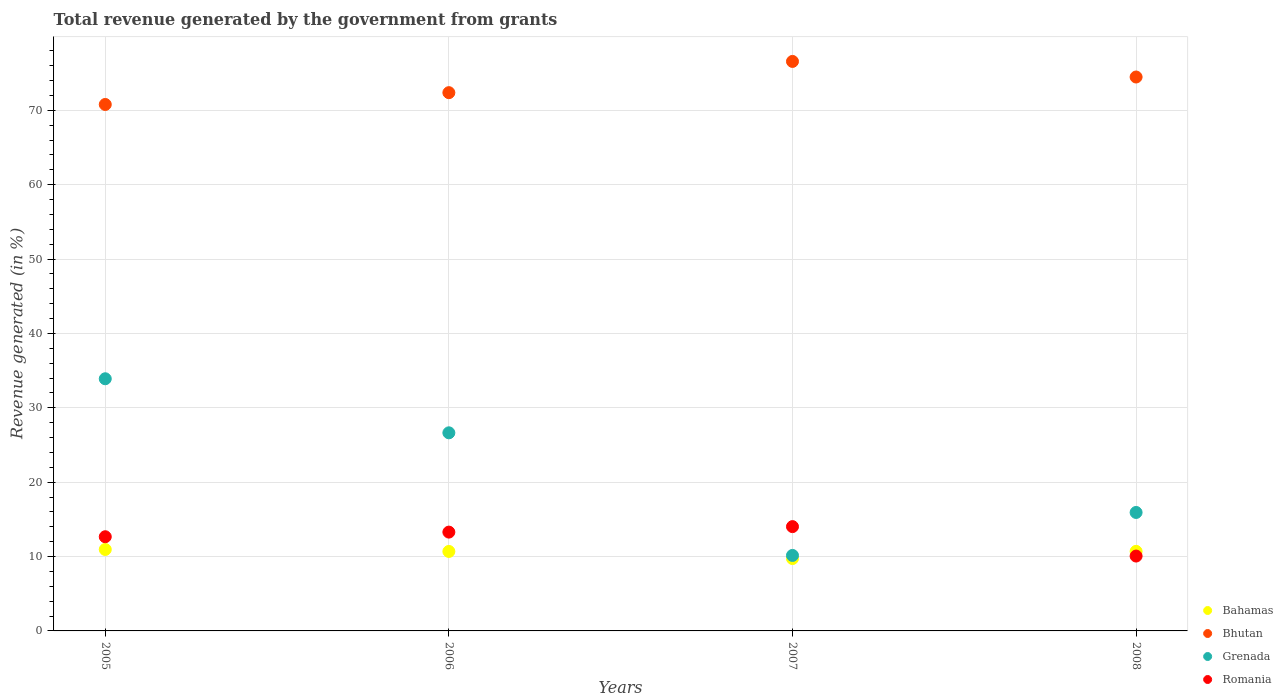How many different coloured dotlines are there?
Offer a very short reply. 4. What is the total revenue generated in Bhutan in 2007?
Your answer should be very brief. 76.57. Across all years, what is the maximum total revenue generated in Grenada?
Offer a very short reply. 33.9. Across all years, what is the minimum total revenue generated in Romania?
Provide a succinct answer. 10.07. In which year was the total revenue generated in Grenada maximum?
Your answer should be very brief. 2005. What is the total total revenue generated in Romania in the graph?
Provide a succinct answer. 50.04. What is the difference between the total revenue generated in Romania in 2007 and that in 2008?
Offer a terse response. 3.96. What is the difference between the total revenue generated in Grenada in 2006 and the total revenue generated in Bhutan in 2007?
Give a very brief answer. -49.93. What is the average total revenue generated in Bhutan per year?
Provide a succinct answer. 73.55. In the year 2008, what is the difference between the total revenue generated in Bhutan and total revenue generated in Romania?
Keep it short and to the point. 64.41. In how many years, is the total revenue generated in Grenada greater than 58 %?
Provide a succinct answer. 0. What is the ratio of the total revenue generated in Bahamas in 2007 to that in 2008?
Offer a terse response. 0.91. What is the difference between the highest and the second highest total revenue generated in Romania?
Provide a succinct answer. 0.74. What is the difference between the highest and the lowest total revenue generated in Bhutan?
Offer a terse response. 5.79. In how many years, is the total revenue generated in Bhutan greater than the average total revenue generated in Bhutan taken over all years?
Your answer should be compact. 2. Is it the case that in every year, the sum of the total revenue generated in Romania and total revenue generated in Bhutan  is greater than the total revenue generated in Grenada?
Give a very brief answer. Yes. Does the total revenue generated in Romania monotonically increase over the years?
Your response must be concise. No. What is the difference between two consecutive major ticks on the Y-axis?
Offer a very short reply. 10. Does the graph contain any zero values?
Provide a short and direct response. No. Does the graph contain grids?
Your answer should be compact. Yes. Where does the legend appear in the graph?
Offer a terse response. Bottom right. How many legend labels are there?
Provide a succinct answer. 4. How are the legend labels stacked?
Provide a short and direct response. Vertical. What is the title of the graph?
Ensure brevity in your answer.  Total revenue generated by the government from grants. Does "Korea (Republic)" appear as one of the legend labels in the graph?
Your response must be concise. No. What is the label or title of the X-axis?
Ensure brevity in your answer.  Years. What is the label or title of the Y-axis?
Your response must be concise. Revenue generated (in %). What is the Revenue generated (in %) of Bahamas in 2005?
Provide a short and direct response. 10.95. What is the Revenue generated (in %) of Bhutan in 2005?
Provide a succinct answer. 70.78. What is the Revenue generated (in %) in Grenada in 2005?
Offer a terse response. 33.9. What is the Revenue generated (in %) in Romania in 2005?
Keep it short and to the point. 12.66. What is the Revenue generated (in %) in Bahamas in 2006?
Your answer should be compact. 10.69. What is the Revenue generated (in %) of Bhutan in 2006?
Give a very brief answer. 72.37. What is the Revenue generated (in %) in Grenada in 2006?
Your answer should be very brief. 26.64. What is the Revenue generated (in %) in Romania in 2006?
Offer a very short reply. 13.29. What is the Revenue generated (in %) in Bahamas in 2007?
Your response must be concise. 9.73. What is the Revenue generated (in %) in Bhutan in 2007?
Your answer should be compact. 76.57. What is the Revenue generated (in %) of Grenada in 2007?
Provide a short and direct response. 10.15. What is the Revenue generated (in %) of Romania in 2007?
Your answer should be very brief. 14.02. What is the Revenue generated (in %) of Bahamas in 2008?
Keep it short and to the point. 10.7. What is the Revenue generated (in %) of Bhutan in 2008?
Keep it short and to the point. 74.48. What is the Revenue generated (in %) in Grenada in 2008?
Offer a terse response. 15.93. What is the Revenue generated (in %) in Romania in 2008?
Provide a succinct answer. 10.07. Across all years, what is the maximum Revenue generated (in %) in Bahamas?
Keep it short and to the point. 10.95. Across all years, what is the maximum Revenue generated (in %) of Bhutan?
Make the answer very short. 76.57. Across all years, what is the maximum Revenue generated (in %) of Grenada?
Your answer should be very brief. 33.9. Across all years, what is the maximum Revenue generated (in %) in Romania?
Keep it short and to the point. 14.02. Across all years, what is the minimum Revenue generated (in %) in Bahamas?
Provide a short and direct response. 9.73. Across all years, what is the minimum Revenue generated (in %) of Bhutan?
Your answer should be compact. 70.78. Across all years, what is the minimum Revenue generated (in %) in Grenada?
Your answer should be very brief. 10.15. Across all years, what is the minimum Revenue generated (in %) of Romania?
Your answer should be very brief. 10.07. What is the total Revenue generated (in %) of Bahamas in the graph?
Offer a very short reply. 42.06. What is the total Revenue generated (in %) of Bhutan in the graph?
Provide a succinct answer. 294.2. What is the total Revenue generated (in %) in Grenada in the graph?
Your response must be concise. 86.62. What is the total Revenue generated (in %) in Romania in the graph?
Keep it short and to the point. 50.04. What is the difference between the Revenue generated (in %) of Bahamas in 2005 and that in 2006?
Offer a terse response. 0.26. What is the difference between the Revenue generated (in %) in Bhutan in 2005 and that in 2006?
Provide a succinct answer. -1.59. What is the difference between the Revenue generated (in %) in Grenada in 2005 and that in 2006?
Make the answer very short. 7.27. What is the difference between the Revenue generated (in %) in Romania in 2005 and that in 2006?
Provide a succinct answer. -0.62. What is the difference between the Revenue generated (in %) of Bahamas in 2005 and that in 2007?
Offer a very short reply. 1.22. What is the difference between the Revenue generated (in %) of Bhutan in 2005 and that in 2007?
Your response must be concise. -5.79. What is the difference between the Revenue generated (in %) of Grenada in 2005 and that in 2007?
Keep it short and to the point. 23.75. What is the difference between the Revenue generated (in %) of Romania in 2005 and that in 2007?
Offer a very short reply. -1.36. What is the difference between the Revenue generated (in %) of Bahamas in 2005 and that in 2008?
Make the answer very short. 0.25. What is the difference between the Revenue generated (in %) in Bhutan in 2005 and that in 2008?
Your response must be concise. -3.69. What is the difference between the Revenue generated (in %) in Grenada in 2005 and that in 2008?
Offer a terse response. 17.98. What is the difference between the Revenue generated (in %) in Romania in 2005 and that in 2008?
Give a very brief answer. 2.6. What is the difference between the Revenue generated (in %) of Bahamas in 2006 and that in 2007?
Your answer should be compact. 0.96. What is the difference between the Revenue generated (in %) of Bhutan in 2006 and that in 2007?
Offer a terse response. -4.2. What is the difference between the Revenue generated (in %) of Grenada in 2006 and that in 2007?
Offer a terse response. 16.49. What is the difference between the Revenue generated (in %) of Romania in 2006 and that in 2007?
Offer a very short reply. -0.74. What is the difference between the Revenue generated (in %) of Bahamas in 2006 and that in 2008?
Give a very brief answer. -0.01. What is the difference between the Revenue generated (in %) of Bhutan in 2006 and that in 2008?
Your response must be concise. -2.1. What is the difference between the Revenue generated (in %) in Grenada in 2006 and that in 2008?
Give a very brief answer. 10.71. What is the difference between the Revenue generated (in %) in Romania in 2006 and that in 2008?
Your answer should be compact. 3.22. What is the difference between the Revenue generated (in %) in Bahamas in 2007 and that in 2008?
Provide a succinct answer. -0.97. What is the difference between the Revenue generated (in %) of Bhutan in 2007 and that in 2008?
Your response must be concise. 2.09. What is the difference between the Revenue generated (in %) of Grenada in 2007 and that in 2008?
Keep it short and to the point. -5.78. What is the difference between the Revenue generated (in %) in Romania in 2007 and that in 2008?
Offer a terse response. 3.96. What is the difference between the Revenue generated (in %) of Bahamas in 2005 and the Revenue generated (in %) of Bhutan in 2006?
Your answer should be very brief. -61.42. What is the difference between the Revenue generated (in %) of Bahamas in 2005 and the Revenue generated (in %) of Grenada in 2006?
Keep it short and to the point. -15.68. What is the difference between the Revenue generated (in %) of Bahamas in 2005 and the Revenue generated (in %) of Romania in 2006?
Offer a terse response. -2.33. What is the difference between the Revenue generated (in %) of Bhutan in 2005 and the Revenue generated (in %) of Grenada in 2006?
Make the answer very short. 44.15. What is the difference between the Revenue generated (in %) of Bhutan in 2005 and the Revenue generated (in %) of Romania in 2006?
Give a very brief answer. 57.5. What is the difference between the Revenue generated (in %) in Grenada in 2005 and the Revenue generated (in %) in Romania in 2006?
Make the answer very short. 20.62. What is the difference between the Revenue generated (in %) of Bahamas in 2005 and the Revenue generated (in %) of Bhutan in 2007?
Your answer should be compact. -65.62. What is the difference between the Revenue generated (in %) in Bahamas in 2005 and the Revenue generated (in %) in Grenada in 2007?
Make the answer very short. 0.8. What is the difference between the Revenue generated (in %) of Bahamas in 2005 and the Revenue generated (in %) of Romania in 2007?
Offer a terse response. -3.07. What is the difference between the Revenue generated (in %) in Bhutan in 2005 and the Revenue generated (in %) in Grenada in 2007?
Your answer should be very brief. 60.63. What is the difference between the Revenue generated (in %) in Bhutan in 2005 and the Revenue generated (in %) in Romania in 2007?
Provide a succinct answer. 56.76. What is the difference between the Revenue generated (in %) of Grenada in 2005 and the Revenue generated (in %) of Romania in 2007?
Your answer should be compact. 19.88. What is the difference between the Revenue generated (in %) in Bahamas in 2005 and the Revenue generated (in %) in Bhutan in 2008?
Your answer should be very brief. -63.52. What is the difference between the Revenue generated (in %) of Bahamas in 2005 and the Revenue generated (in %) of Grenada in 2008?
Keep it short and to the point. -4.98. What is the difference between the Revenue generated (in %) of Bahamas in 2005 and the Revenue generated (in %) of Romania in 2008?
Your answer should be compact. 0.89. What is the difference between the Revenue generated (in %) in Bhutan in 2005 and the Revenue generated (in %) in Grenada in 2008?
Your answer should be compact. 54.85. What is the difference between the Revenue generated (in %) in Bhutan in 2005 and the Revenue generated (in %) in Romania in 2008?
Your answer should be compact. 60.72. What is the difference between the Revenue generated (in %) in Grenada in 2005 and the Revenue generated (in %) in Romania in 2008?
Offer a terse response. 23.84. What is the difference between the Revenue generated (in %) of Bahamas in 2006 and the Revenue generated (in %) of Bhutan in 2007?
Make the answer very short. -65.88. What is the difference between the Revenue generated (in %) of Bahamas in 2006 and the Revenue generated (in %) of Grenada in 2007?
Keep it short and to the point. 0.54. What is the difference between the Revenue generated (in %) of Bahamas in 2006 and the Revenue generated (in %) of Romania in 2007?
Make the answer very short. -3.34. What is the difference between the Revenue generated (in %) in Bhutan in 2006 and the Revenue generated (in %) in Grenada in 2007?
Your answer should be compact. 62.22. What is the difference between the Revenue generated (in %) in Bhutan in 2006 and the Revenue generated (in %) in Romania in 2007?
Provide a succinct answer. 58.35. What is the difference between the Revenue generated (in %) in Grenada in 2006 and the Revenue generated (in %) in Romania in 2007?
Provide a succinct answer. 12.61. What is the difference between the Revenue generated (in %) in Bahamas in 2006 and the Revenue generated (in %) in Bhutan in 2008?
Your answer should be compact. -63.79. What is the difference between the Revenue generated (in %) of Bahamas in 2006 and the Revenue generated (in %) of Grenada in 2008?
Provide a short and direct response. -5.24. What is the difference between the Revenue generated (in %) in Bahamas in 2006 and the Revenue generated (in %) in Romania in 2008?
Give a very brief answer. 0.62. What is the difference between the Revenue generated (in %) of Bhutan in 2006 and the Revenue generated (in %) of Grenada in 2008?
Make the answer very short. 56.44. What is the difference between the Revenue generated (in %) of Bhutan in 2006 and the Revenue generated (in %) of Romania in 2008?
Your answer should be compact. 62.31. What is the difference between the Revenue generated (in %) of Grenada in 2006 and the Revenue generated (in %) of Romania in 2008?
Make the answer very short. 16.57. What is the difference between the Revenue generated (in %) in Bahamas in 2007 and the Revenue generated (in %) in Bhutan in 2008?
Keep it short and to the point. -64.75. What is the difference between the Revenue generated (in %) of Bahamas in 2007 and the Revenue generated (in %) of Grenada in 2008?
Offer a terse response. -6.2. What is the difference between the Revenue generated (in %) in Bahamas in 2007 and the Revenue generated (in %) in Romania in 2008?
Give a very brief answer. -0.34. What is the difference between the Revenue generated (in %) of Bhutan in 2007 and the Revenue generated (in %) of Grenada in 2008?
Provide a succinct answer. 60.64. What is the difference between the Revenue generated (in %) in Bhutan in 2007 and the Revenue generated (in %) in Romania in 2008?
Offer a terse response. 66.5. What is the difference between the Revenue generated (in %) of Grenada in 2007 and the Revenue generated (in %) of Romania in 2008?
Your response must be concise. 0.08. What is the average Revenue generated (in %) of Bahamas per year?
Your response must be concise. 10.52. What is the average Revenue generated (in %) of Bhutan per year?
Make the answer very short. 73.55. What is the average Revenue generated (in %) of Grenada per year?
Your answer should be very brief. 21.65. What is the average Revenue generated (in %) in Romania per year?
Provide a succinct answer. 12.51. In the year 2005, what is the difference between the Revenue generated (in %) in Bahamas and Revenue generated (in %) in Bhutan?
Ensure brevity in your answer.  -59.83. In the year 2005, what is the difference between the Revenue generated (in %) of Bahamas and Revenue generated (in %) of Grenada?
Your response must be concise. -22.95. In the year 2005, what is the difference between the Revenue generated (in %) of Bahamas and Revenue generated (in %) of Romania?
Make the answer very short. -1.71. In the year 2005, what is the difference between the Revenue generated (in %) in Bhutan and Revenue generated (in %) in Grenada?
Make the answer very short. 36.88. In the year 2005, what is the difference between the Revenue generated (in %) of Bhutan and Revenue generated (in %) of Romania?
Your answer should be very brief. 58.12. In the year 2005, what is the difference between the Revenue generated (in %) in Grenada and Revenue generated (in %) in Romania?
Provide a short and direct response. 21.24. In the year 2006, what is the difference between the Revenue generated (in %) of Bahamas and Revenue generated (in %) of Bhutan?
Give a very brief answer. -61.69. In the year 2006, what is the difference between the Revenue generated (in %) in Bahamas and Revenue generated (in %) in Grenada?
Provide a succinct answer. -15.95. In the year 2006, what is the difference between the Revenue generated (in %) in Bahamas and Revenue generated (in %) in Romania?
Provide a succinct answer. -2.6. In the year 2006, what is the difference between the Revenue generated (in %) in Bhutan and Revenue generated (in %) in Grenada?
Your response must be concise. 45.74. In the year 2006, what is the difference between the Revenue generated (in %) of Bhutan and Revenue generated (in %) of Romania?
Keep it short and to the point. 59.09. In the year 2006, what is the difference between the Revenue generated (in %) in Grenada and Revenue generated (in %) in Romania?
Provide a short and direct response. 13.35. In the year 2007, what is the difference between the Revenue generated (in %) of Bahamas and Revenue generated (in %) of Bhutan?
Offer a very short reply. -66.84. In the year 2007, what is the difference between the Revenue generated (in %) of Bahamas and Revenue generated (in %) of Grenada?
Provide a short and direct response. -0.42. In the year 2007, what is the difference between the Revenue generated (in %) of Bahamas and Revenue generated (in %) of Romania?
Provide a succinct answer. -4.29. In the year 2007, what is the difference between the Revenue generated (in %) of Bhutan and Revenue generated (in %) of Grenada?
Provide a short and direct response. 66.42. In the year 2007, what is the difference between the Revenue generated (in %) in Bhutan and Revenue generated (in %) in Romania?
Offer a terse response. 62.55. In the year 2007, what is the difference between the Revenue generated (in %) in Grenada and Revenue generated (in %) in Romania?
Give a very brief answer. -3.87. In the year 2008, what is the difference between the Revenue generated (in %) in Bahamas and Revenue generated (in %) in Bhutan?
Ensure brevity in your answer.  -63.78. In the year 2008, what is the difference between the Revenue generated (in %) of Bahamas and Revenue generated (in %) of Grenada?
Ensure brevity in your answer.  -5.23. In the year 2008, what is the difference between the Revenue generated (in %) of Bahamas and Revenue generated (in %) of Romania?
Offer a very short reply. 0.63. In the year 2008, what is the difference between the Revenue generated (in %) of Bhutan and Revenue generated (in %) of Grenada?
Your answer should be very brief. 58.55. In the year 2008, what is the difference between the Revenue generated (in %) in Bhutan and Revenue generated (in %) in Romania?
Your answer should be compact. 64.41. In the year 2008, what is the difference between the Revenue generated (in %) in Grenada and Revenue generated (in %) in Romania?
Your answer should be compact. 5.86. What is the ratio of the Revenue generated (in %) in Bahamas in 2005 to that in 2006?
Give a very brief answer. 1.02. What is the ratio of the Revenue generated (in %) in Bhutan in 2005 to that in 2006?
Give a very brief answer. 0.98. What is the ratio of the Revenue generated (in %) in Grenada in 2005 to that in 2006?
Your answer should be very brief. 1.27. What is the ratio of the Revenue generated (in %) of Romania in 2005 to that in 2006?
Make the answer very short. 0.95. What is the ratio of the Revenue generated (in %) of Bahamas in 2005 to that in 2007?
Offer a terse response. 1.13. What is the ratio of the Revenue generated (in %) of Bhutan in 2005 to that in 2007?
Your response must be concise. 0.92. What is the ratio of the Revenue generated (in %) of Grenada in 2005 to that in 2007?
Keep it short and to the point. 3.34. What is the ratio of the Revenue generated (in %) of Romania in 2005 to that in 2007?
Ensure brevity in your answer.  0.9. What is the ratio of the Revenue generated (in %) in Bahamas in 2005 to that in 2008?
Your answer should be compact. 1.02. What is the ratio of the Revenue generated (in %) of Bhutan in 2005 to that in 2008?
Provide a short and direct response. 0.95. What is the ratio of the Revenue generated (in %) of Grenada in 2005 to that in 2008?
Keep it short and to the point. 2.13. What is the ratio of the Revenue generated (in %) in Romania in 2005 to that in 2008?
Your answer should be very brief. 1.26. What is the ratio of the Revenue generated (in %) of Bahamas in 2006 to that in 2007?
Your response must be concise. 1.1. What is the ratio of the Revenue generated (in %) of Bhutan in 2006 to that in 2007?
Provide a succinct answer. 0.95. What is the ratio of the Revenue generated (in %) of Grenada in 2006 to that in 2007?
Your answer should be very brief. 2.62. What is the ratio of the Revenue generated (in %) of Romania in 2006 to that in 2007?
Ensure brevity in your answer.  0.95. What is the ratio of the Revenue generated (in %) of Bahamas in 2006 to that in 2008?
Give a very brief answer. 1. What is the ratio of the Revenue generated (in %) of Bhutan in 2006 to that in 2008?
Offer a terse response. 0.97. What is the ratio of the Revenue generated (in %) of Grenada in 2006 to that in 2008?
Offer a very short reply. 1.67. What is the ratio of the Revenue generated (in %) of Romania in 2006 to that in 2008?
Ensure brevity in your answer.  1.32. What is the ratio of the Revenue generated (in %) in Bahamas in 2007 to that in 2008?
Make the answer very short. 0.91. What is the ratio of the Revenue generated (in %) of Bhutan in 2007 to that in 2008?
Give a very brief answer. 1.03. What is the ratio of the Revenue generated (in %) in Grenada in 2007 to that in 2008?
Make the answer very short. 0.64. What is the ratio of the Revenue generated (in %) of Romania in 2007 to that in 2008?
Offer a terse response. 1.39. What is the difference between the highest and the second highest Revenue generated (in %) of Bahamas?
Provide a short and direct response. 0.25. What is the difference between the highest and the second highest Revenue generated (in %) in Bhutan?
Ensure brevity in your answer.  2.09. What is the difference between the highest and the second highest Revenue generated (in %) of Grenada?
Provide a succinct answer. 7.27. What is the difference between the highest and the second highest Revenue generated (in %) in Romania?
Your answer should be very brief. 0.74. What is the difference between the highest and the lowest Revenue generated (in %) of Bahamas?
Keep it short and to the point. 1.22. What is the difference between the highest and the lowest Revenue generated (in %) in Bhutan?
Make the answer very short. 5.79. What is the difference between the highest and the lowest Revenue generated (in %) of Grenada?
Ensure brevity in your answer.  23.75. What is the difference between the highest and the lowest Revenue generated (in %) in Romania?
Provide a succinct answer. 3.96. 